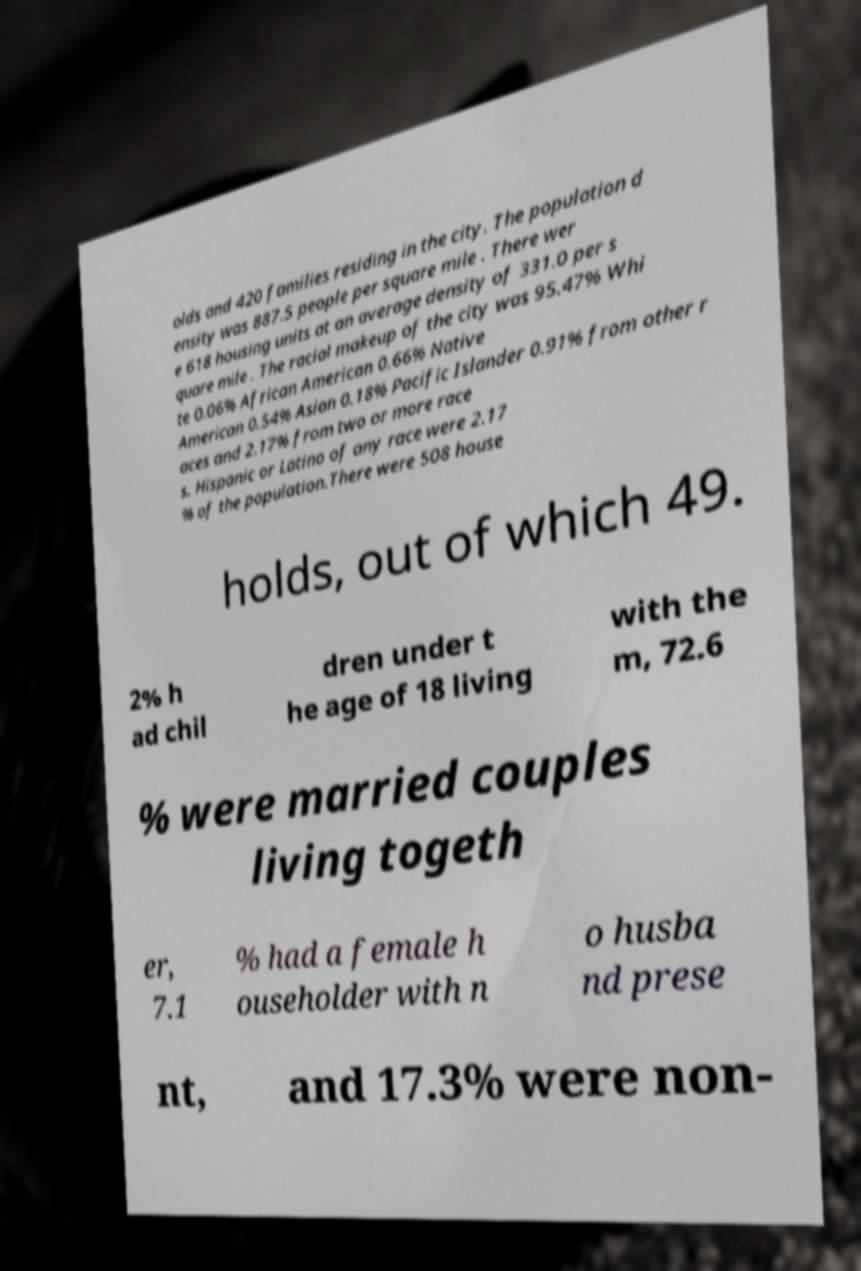For documentation purposes, I need the text within this image transcribed. Could you provide that? olds and 420 families residing in the city. The population d ensity was 887.5 people per square mile . There wer e 618 housing units at an average density of 331.0 per s quare mile . The racial makeup of the city was 95.47% Whi te 0.06% African American 0.66% Native American 0.54% Asian 0.18% Pacific Islander 0.91% from other r aces and 2.17% from two or more race s. Hispanic or Latino of any race were 2.17 % of the population.There were 508 house holds, out of which 49. 2% h ad chil dren under t he age of 18 living with the m, 72.6 % were married couples living togeth er, 7.1 % had a female h ouseholder with n o husba nd prese nt, and 17.3% were non- 